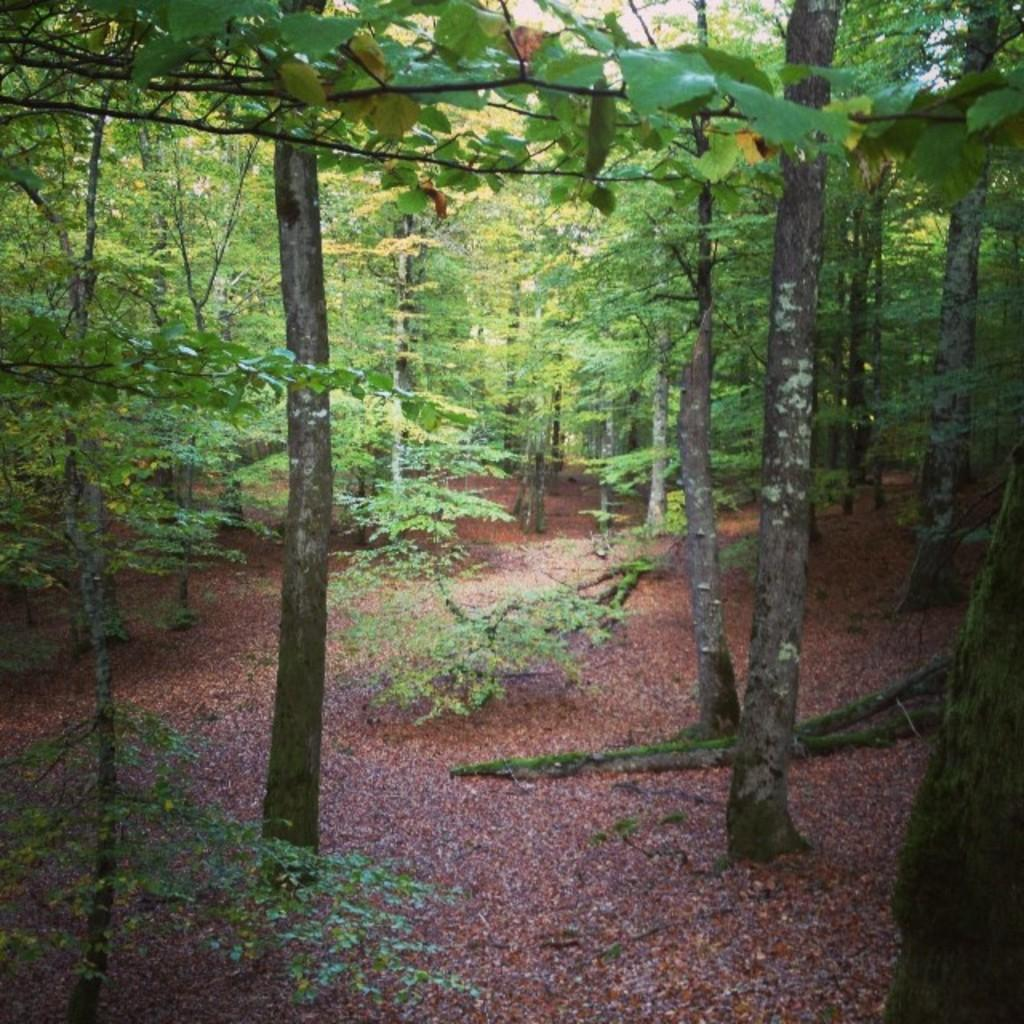What can be seen in the foreground of the picture? There are dry leaves and trees in the foreground of the picture. Are there any trees visible in the background of the picture? Yes, there are trees in the background of the picture. What type of cracker is being used to clean the oven in the image? There is no oven or cracker present in the image. 